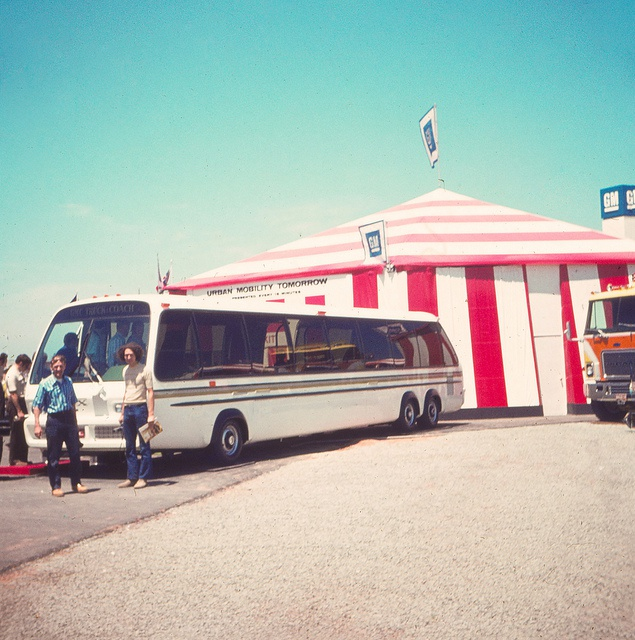Describe the objects in this image and their specific colors. I can see bus in teal, gray, ivory, lightgray, and black tones, truck in teal, gray, beige, and black tones, people in teal, black, gray, and purple tones, people in teal, gray, navy, and ivory tones, and people in teal, black, gray, and ivory tones in this image. 